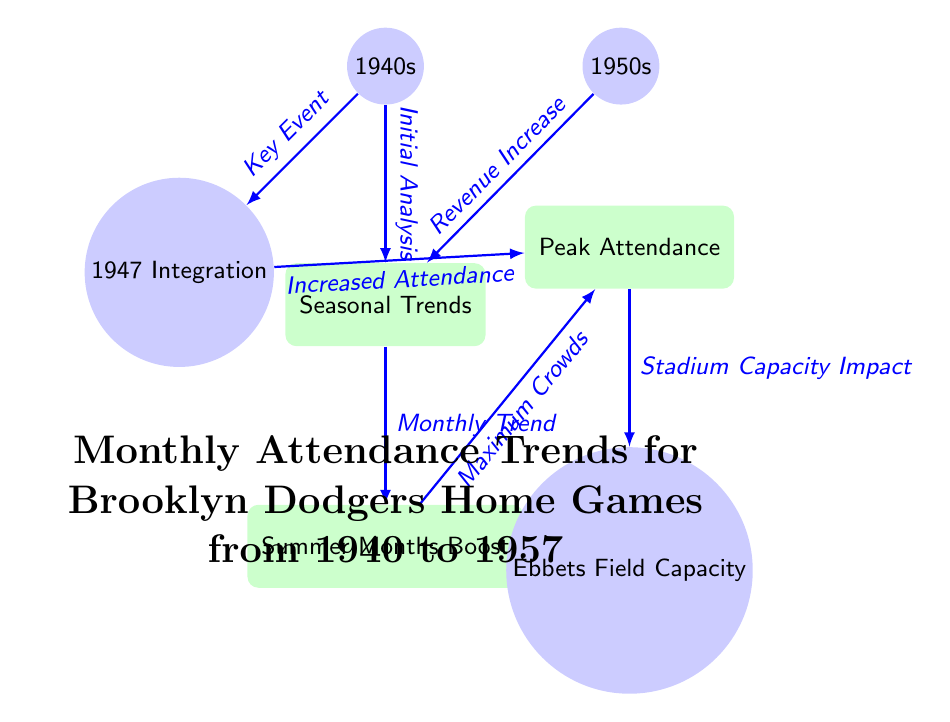What are the two decades represented in the diagram? The nodes directly labeled at the top of the diagram indicate the decades represented: one node shows "1940s" and the other shows "1950s."
Answer: 1940s, 1950s What event is linked to increased attendance? The diagram connects "1947 Integration" to the node "Increased Attendance," indicating this as the key event affecting attendance.
Answer: 1947 Integration What is one reason for the monthly attendance trends? The edge connecting "Seasonal Trends" to "Summer Months Boost" implies that summer months positively influenced attendance trends.
Answer: Summer Months Boost What is the maximum attendance described in relation to stadium capacity? The arrow from "Peak Attendance" points to "Ebbets Field Capacity," suggesting the peak attendance is limited by the stadium's capacity.
Answer: Stadium Capacity How many key concepts are there about peak attendance in this diagram? The node "Peak Attendance" is influenced by both "Increased Attendance" (from "1947 Integration") and "Maximum Crowds," suggesting two concepts relate to peak attendance.
Answer: 2 What trend is noted in the diagram regarding attendance over time? The edge from "Initial Analysis" to "Seasonal Trends" indicates attendance reflects seasonal variations, framing the shows as subject to trends across time.
Answer: Seasonal Trends Which decade is associated with a revenue increase? The flow in the diagram illustrates an edge pointing from "1950s" to "Seasonal Trends," inferring revenue increase links to the 1950s specifically.
Answer: 1950s What is the relationship between stadium capacity and peak attendance? Attendance trends flow from "Peak Attendance" to "Ebbets Field Capacity," suggesting that the stadium's capacity directly impacts the levels of peak attendance.
Answer: Direct Impact 